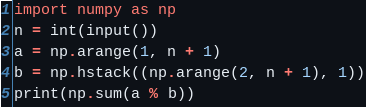Convert code to text. <code><loc_0><loc_0><loc_500><loc_500><_Python_>import numpy as np
n = int(input())
a = np.arange(1, n + 1)
b = np.hstack((np.arange(2, n + 1), 1))
print(np.sum(a % b))</code> 